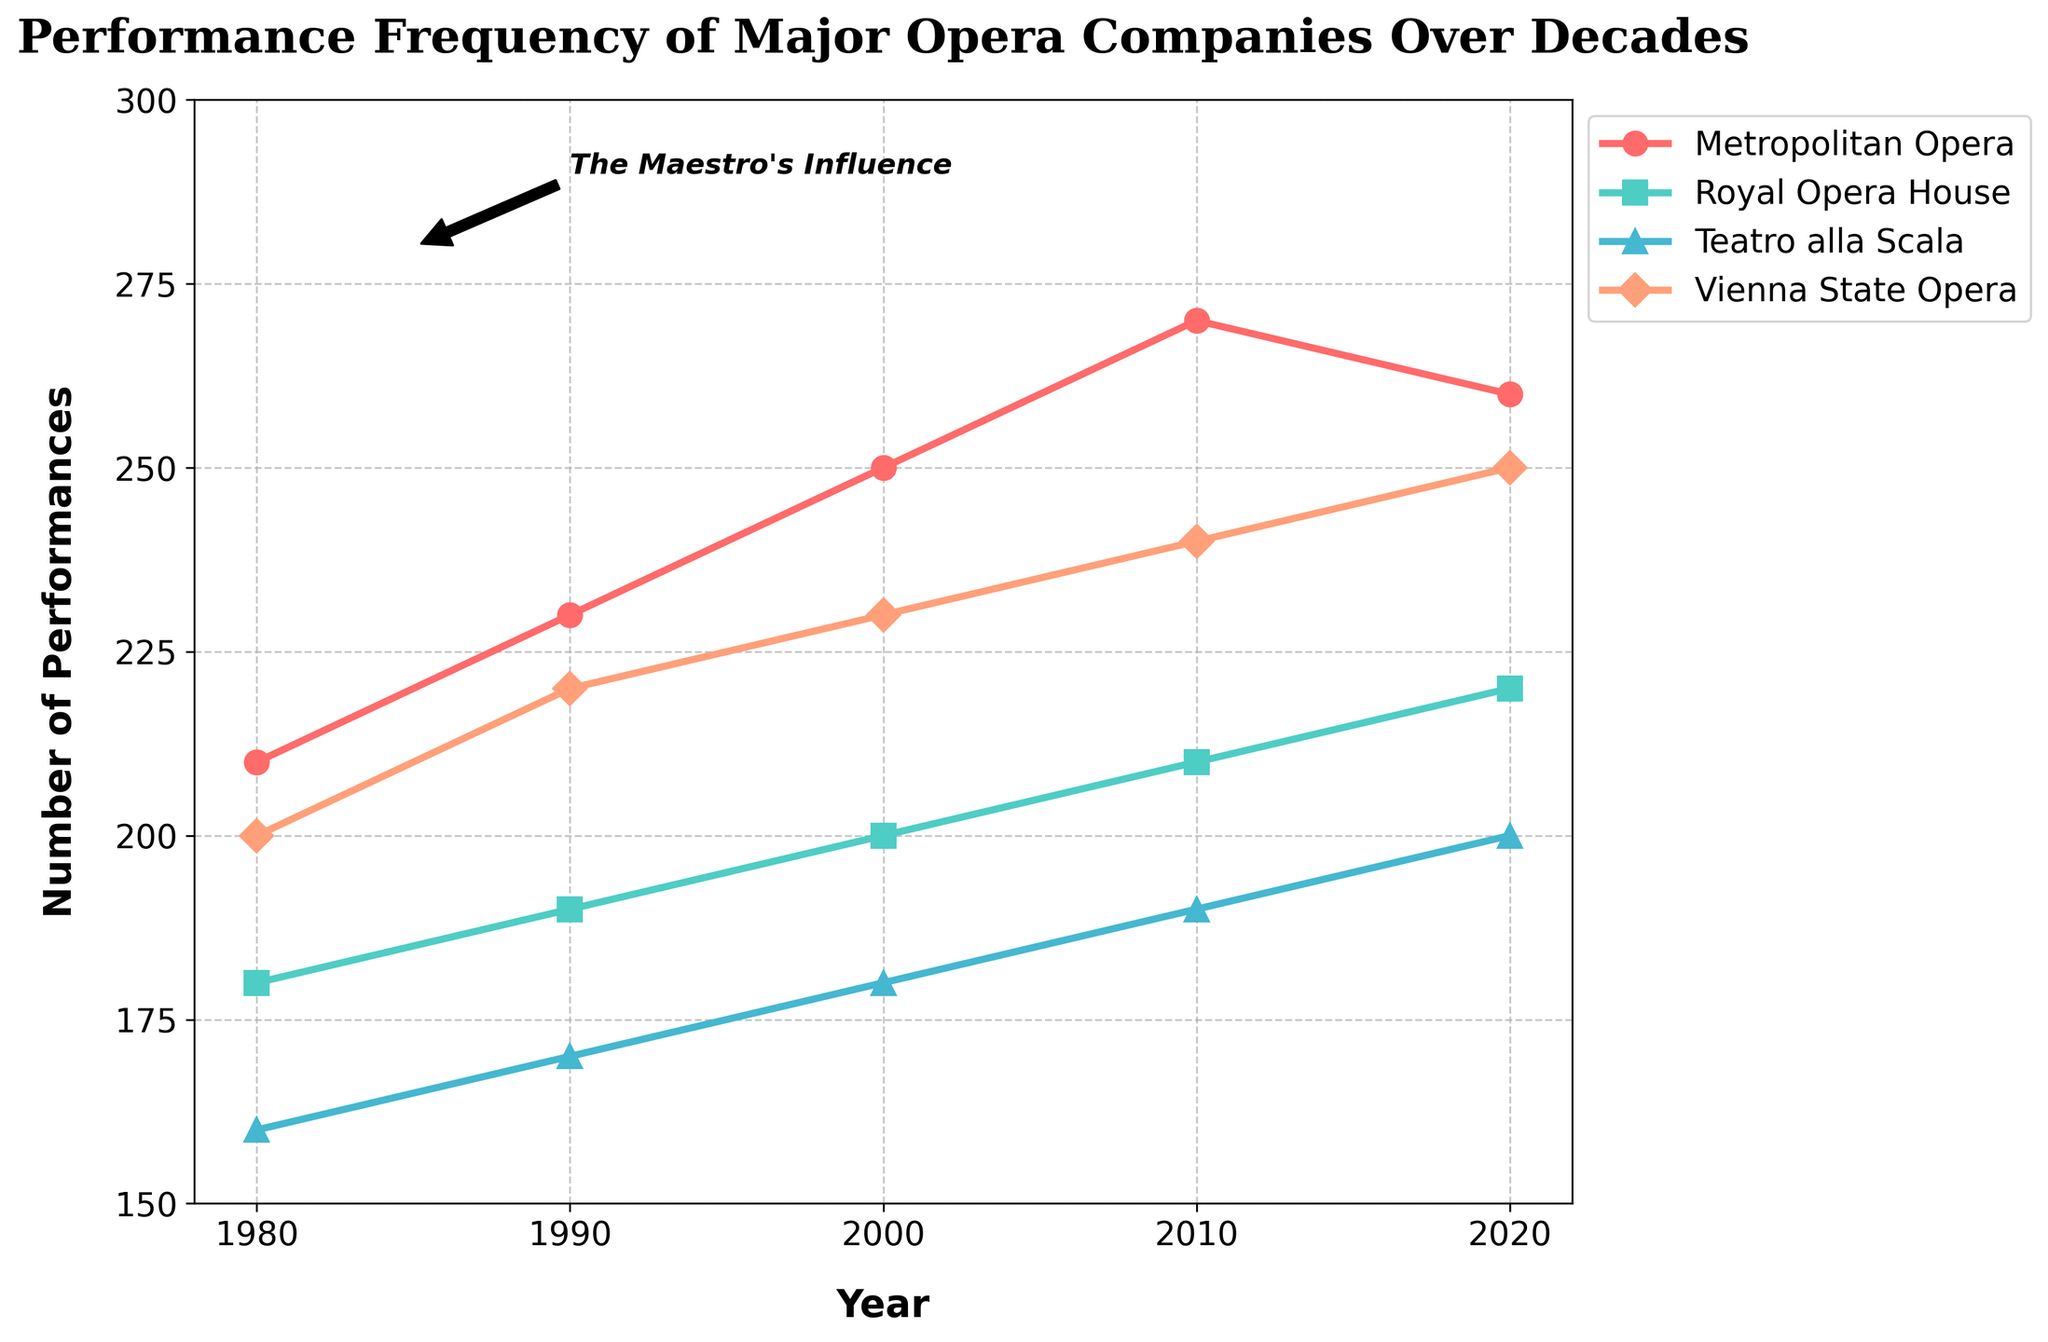What is the title of the plot? The title is the text located at the top center of the plot. It provides a brief description of the content or purpose of the plot.
Answer: Performance Frequency of Major Opera Companies Over Decades How many opera companies are displayed in the plot? By counting the distinct labels in the legend or unique lines in the plot, we can determine the number of companies being represented.
Answer: Four What is the color of the line representing the Royal Opera House? By examining the legend, the Royal Opera House is matched with its corresponding line color in the plot.
Answer: Turquoise How many performances did the Metropolitan Opera have in 2010? Locate the year 2010 on the x-axis, then trace it vertically to the corresponding point of the Metropolitan Opera line and read the y-axis value.
Answer: 270 What is the overall trend for Teatro alla Scala from 1980 to 2020? Observe the line for Teatro alla Scala across the x-axis from 1980 to 2020 to identify the overall direction (increasing, decreasing, or stable).
Answer: Increasing Which opera company had the highest number of performances in 2020? Compare the y-axis values of all lines at the year 2020 to see which one reaches the highest point.
Answer: Metropolitan Opera What is the average number of performances for the Vienna State Opera over the decades shown? Sum the number of performances by the Vienna State Opera in each decade (200 + 220 + 230 + 240 + 250) and divide by the number of decades (5).
Answer: 228 Between 2000 and 2010, which opera company saw the greatest increase in the number of performances? For each company, find the difference in y-axis values between 2000 and 2010. Compare these differences to determine the greatest increase.
Answer: Metropolitan Opera How does the performance frequency of the Royal Opera House in 2020 compare to that in 1980? Locate the y-axis values for the Royal Opera House in 2020 and 1980, and compare these two values to see the difference or relationship.
Answer: Increased by 40 performances What annotation is included in the plot and what might its significance be? Examine the plot for any textual annotations, then think about its potential relevance to the data trends.
Answer: The annotation is "The Maestro's Influence" and it may indicate a significant impact on performance frequencies starting around this period 